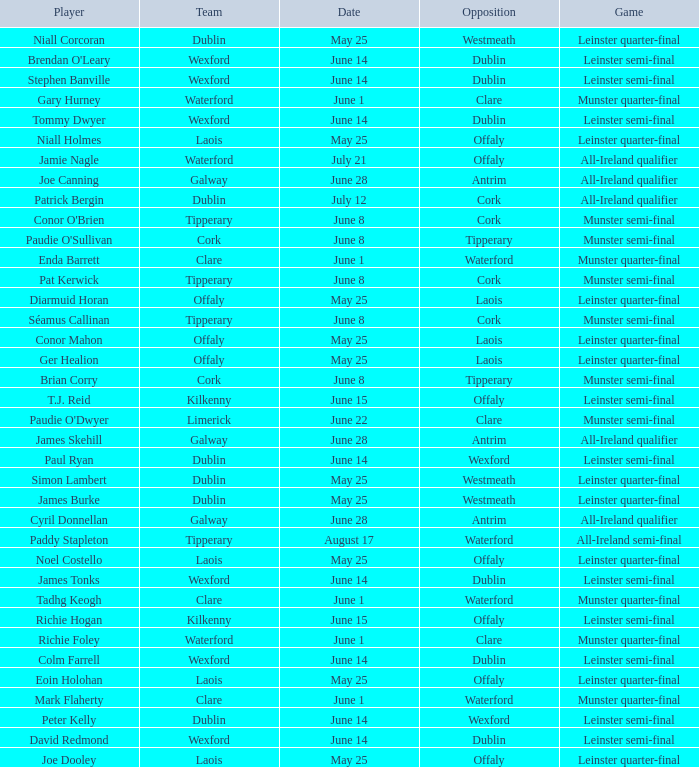What game did Eoin Holohan play in? Leinster quarter-final. 